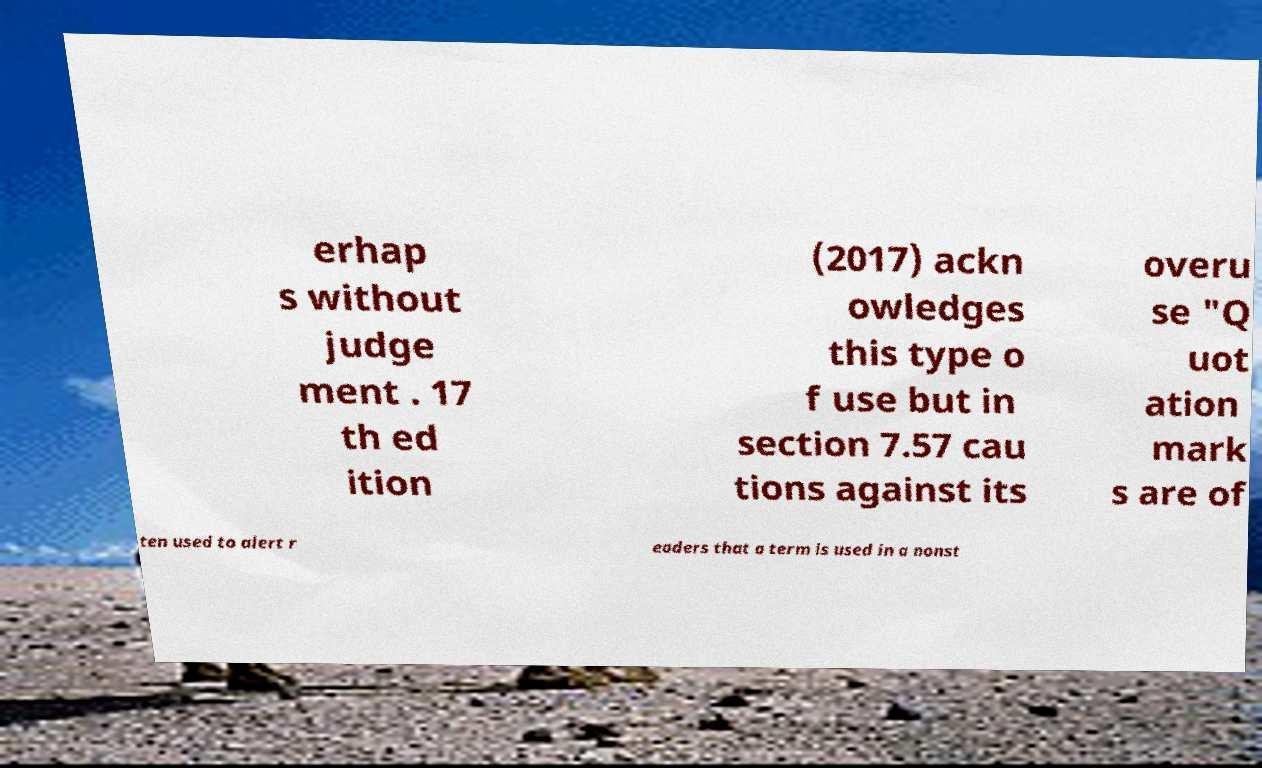For documentation purposes, I need the text within this image transcribed. Could you provide that? erhap s without judge ment . 17 th ed ition (2017) ackn owledges this type o f use but in section 7.57 cau tions against its overu se "Q uot ation mark s are of ten used to alert r eaders that a term is used in a nonst 